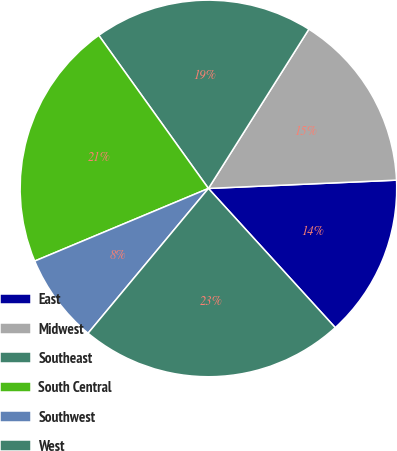<chart> <loc_0><loc_0><loc_500><loc_500><pie_chart><fcel>East<fcel>Midwest<fcel>Southeast<fcel>South Central<fcel>Southwest<fcel>West<nl><fcel>13.94%<fcel>15.34%<fcel>18.85%<fcel>21.41%<fcel>7.66%<fcel>22.8%<nl></chart> 